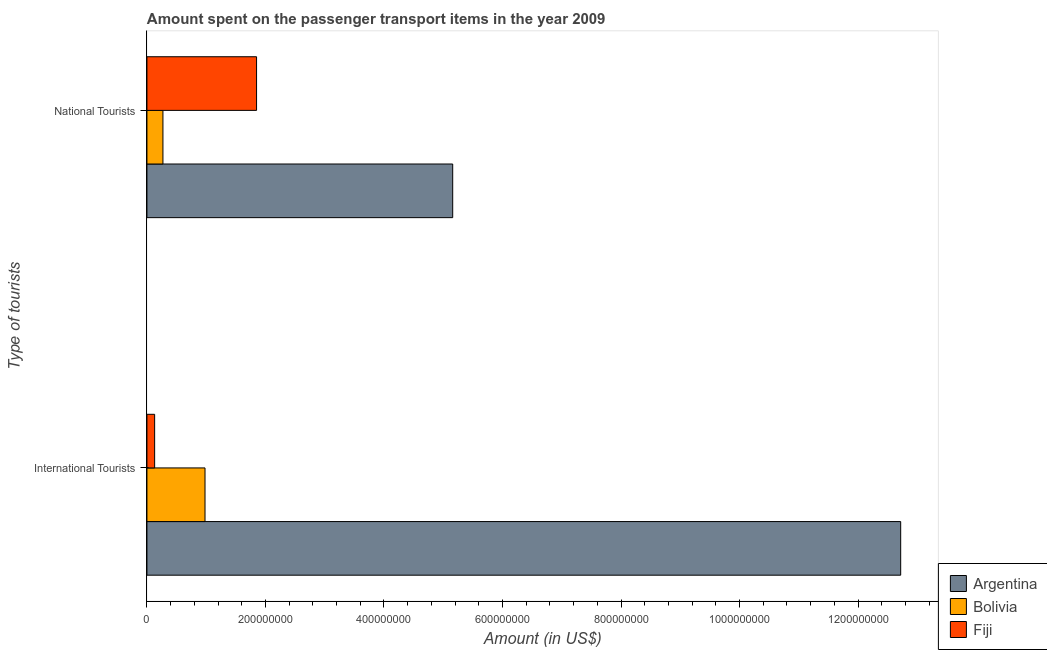How many groups of bars are there?
Give a very brief answer. 2. How many bars are there on the 1st tick from the bottom?
Offer a terse response. 3. What is the label of the 1st group of bars from the top?
Offer a very short reply. National Tourists. What is the amount spent on transport items of national tourists in Fiji?
Make the answer very short. 1.85e+08. Across all countries, what is the maximum amount spent on transport items of international tourists?
Make the answer very short. 1.27e+09. Across all countries, what is the minimum amount spent on transport items of international tourists?
Your answer should be compact. 1.30e+07. In which country was the amount spent on transport items of international tourists minimum?
Ensure brevity in your answer.  Fiji. What is the total amount spent on transport items of national tourists in the graph?
Your answer should be very brief. 7.28e+08. What is the difference between the amount spent on transport items of international tourists in Fiji and that in Bolivia?
Provide a short and direct response. -8.50e+07. What is the difference between the amount spent on transport items of national tourists in Fiji and the amount spent on transport items of international tourists in Bolivia?
Offer a very short reply. 8.70e+07. What is the average amount spent on transport items of national tourists per country?
Your response must be concise. 2.43e+08. What is the difference between the amount spent on transport items of national tourists and amount spent on transport items of international tourists in Bolivia?
Ensure brevity in your answer.  -7.10e+07. What is the ratio of the amount spent on transport items of national tourists in Bolivia to that in Fiji?
Provide a short and direct response. 0.15. Is the amount spent on transport items of international tourists in Argentina less than that in Fiji?
Your answer should be very brief. No. In how many countries, is the amount spent on transport items of national tourists greater than the average amount spent on transport items of national tourists taken over all countries?
Ensure brevity in your answer.  1. What is the difference between two consecutive major ticks on the X-axis?
Your response must be concise. 2.00e+08. Are the values on the major ticks of X-axis written in scientific E-notation?
Provide a succinct answer. No. Where does the legend appear in the graph?
Offer a terse response. Bottom right. How are the legend labels stacked?
Keep it short and to the point. Vertical. What is the title of the graph?
Your answer should be compact. Amount spent on the passenger transport items in the year 2009. Does "Armenia" appear as one of the legend labels in the graph?
Offer a very short reply. No. What is the label or title of the Y-axis?
Give a very brief answer. Type of tourists. What is the Amount (in US$) in Argentina in International Tourists?
Your answer should be compact. 1.27e+09. What is the Amount (in US$) in Bolivia in International Tourists?
Give a very brief answer. 9.80e+07. What is the Amount (in US$) of Fiji in International Tourists?
Provide a succinct answer. 1.30e+07. What is the Amount (in US$) in Argentina in National Tourists?
Give a very brief answer. 5.16e+08. What is the Amount (in US$) in Bolivia in National Tourists?
Make the answer very short. 2.70e+07. What is the Amount (in US$) in Fiji in National Tourists?
Provide a short and direct response. 1.85e+08. Across all Type of tourists, what is the maximum Amount (in US$) of Argentina?
Give a very brief answer. 1.27e+09. Across all Type of tourists, what is the maximum Amount (in US$) in Bolivia?
Keep it short and to the point. 9.80e+07. Across all Type of tourists, what is the maximum Amount (in US$) in Fiji?
Provide a succinct answer. 1.85e+08. Across all Type of tourists, what is the minimum Amount (in US$) of Argentina?
Give a very brief answer. 5.16e+08. Across all Type of tourists, what is the minimum Amount (in US$) in Bolivia?
Make the answer very short. 2.70e+07. Across all Type of tourists, what is the minimum Amount (in US$) of Fiji?
Keep it short and to the point. 1.30e+07. What is the total Amount (in US$) in Argentina in the graph?
Offer a very short reply. 1.79e+09. What is the total Amount (in US$) of Bolivia in the graph?
Your response must be concise. 1.25e+08. What is the total Amount (in US$) of Fiji in the graph?
Provide a succinct answer. 1.98e+08. What is the difference between the Amount (in US$) in Argentina in International Tourists and that in National Tourists?
Provide a short and direct response. 7.56e+08. What is the difference between the Amount (in US$) of Bolivia in International Tourists and that in National Tourists?
Offer a very short reply. 7.10e+07. What is the difference between the Amount (in US$) of Fiji in International Tourists and that in National Tourists?
Offer a very short reply. -1.72e+08. What is the difference between the Amount (in US$) of Argentina in International Tourists and the Amount (in US$) of Bolivia in National Tourists?
Your answer should be compact. 1.24e+09. What is the difference between the Amount (in US$) of Argentina in International Tourists and the Amount (in US$) of Fiji in National Tourists?
Ensure brevity in your answer.  1.09e+09. What is the difference between the Amount (in US$) in Bolivia in International Tourists and the Amount (in US$) in Fiji in National Tourists?
Keep it short and to the point. -8.70e+07. What is the average Amount (in US$) in Argentina per Type of tourists?
Your answer should be very brief. 8.94e+08. What is the average Amount (in US$) in Bolivia per Type of tourists?
Keep it short and to the point. 6.25e+07. What is the average Amount (in US$) in Fiji per Type of tourists?
Your answer should be very brief. 9.90e+07. What is the difference between the Amount (in US$) of Argentina and Amount (in US$) of Bolivia in International Tourists?
Provide a short and direct response. 1.17e+09. What is the difference between the Amount (in US$) in Argentina and Amount (in US$) in Fiji in International Tourists?
Provide a short and direct response. 1.26e+09. What is the difference between the Amount (in US$) of Bolivia and Amount (in US$) of Fiji in International Tourists?
Give a very brief answer. 8.50e+07. What is the difference between the Amount (in US$) in Argentina and Amount (in US$) in Bolivia in National Tourists?
Your answer should be very brief. 4.89e+08. What is the difference between the Amount (in US$) in Argentina and Amount (in US$) in Fiji in National Tourists?
Provide a succinct answer. 3.31e+08. What is the difference between the Amount (in US$) in Bolivia and Amount (in US$) in Fiji in National Tourists?
Provide a short and direct response. -1.58e+08. What is the ratio of the Amount (in US$) of Argentina in International Tourists to that in National Tourists?
Offer a very short reply. 2.47. What is the ratio of the Amount (in US$) of Bolivia in International Tourists to that in National Tourists?
Provide a succinct answer. 3.63. What is the ratio of the Amount (in US$) in Fiji in International Tourists to that in National Tourists?
Ensure brevity in your answer.  0.07. What is the difference between the highest and the second highest Amount (in US$) of Argentina?
Give a very brief answer. 7.56e+08. What is the difference between the highest and the second highest Amount (in US$) of Bolivia?
Make the answer very short. 7.10e+07. What is the difference between the highest and the second highest Amount (in US$) of Fiji?
Your answer should be very brief. 1.72e+08. What is the difference between the highest and the lowest Amount (in US$) in Argentina?
Provide a succinct answer. 7.56e+08. What is the difference between the highest and the lowest Amount (in US$) in Bolivia?
Offer a terse response. 7.10e+07. What is the difference between the highest and the lowest Amount (in US$) of Fiji?
Provide a short and direct response. 1.72e+08. 